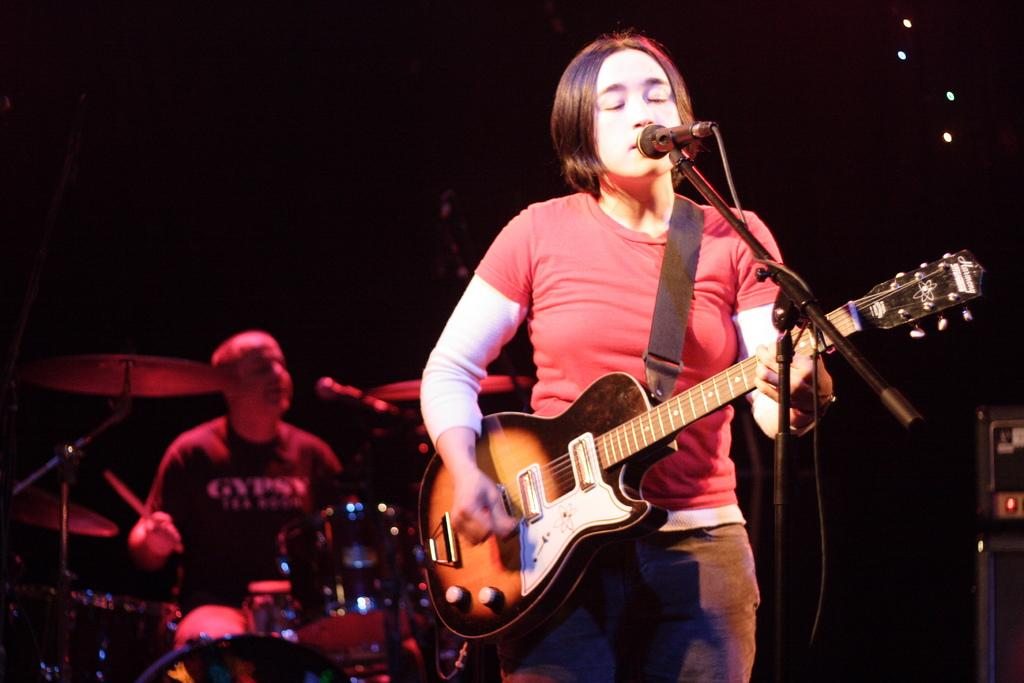What is the overall color scheme of the image? The background of the image is dark. What is the person in the image doing? The person is standing in front of a microphone and playing a guitar. Are there any other musicians in the image? Yes, there is a man playing drums in the background. What type of arch can be seen in the background of the image? There is no arch present in the image. Can you describe the field where the musicians are performing? There is no field mentioned in the image; it appears to be an indoor setting. 